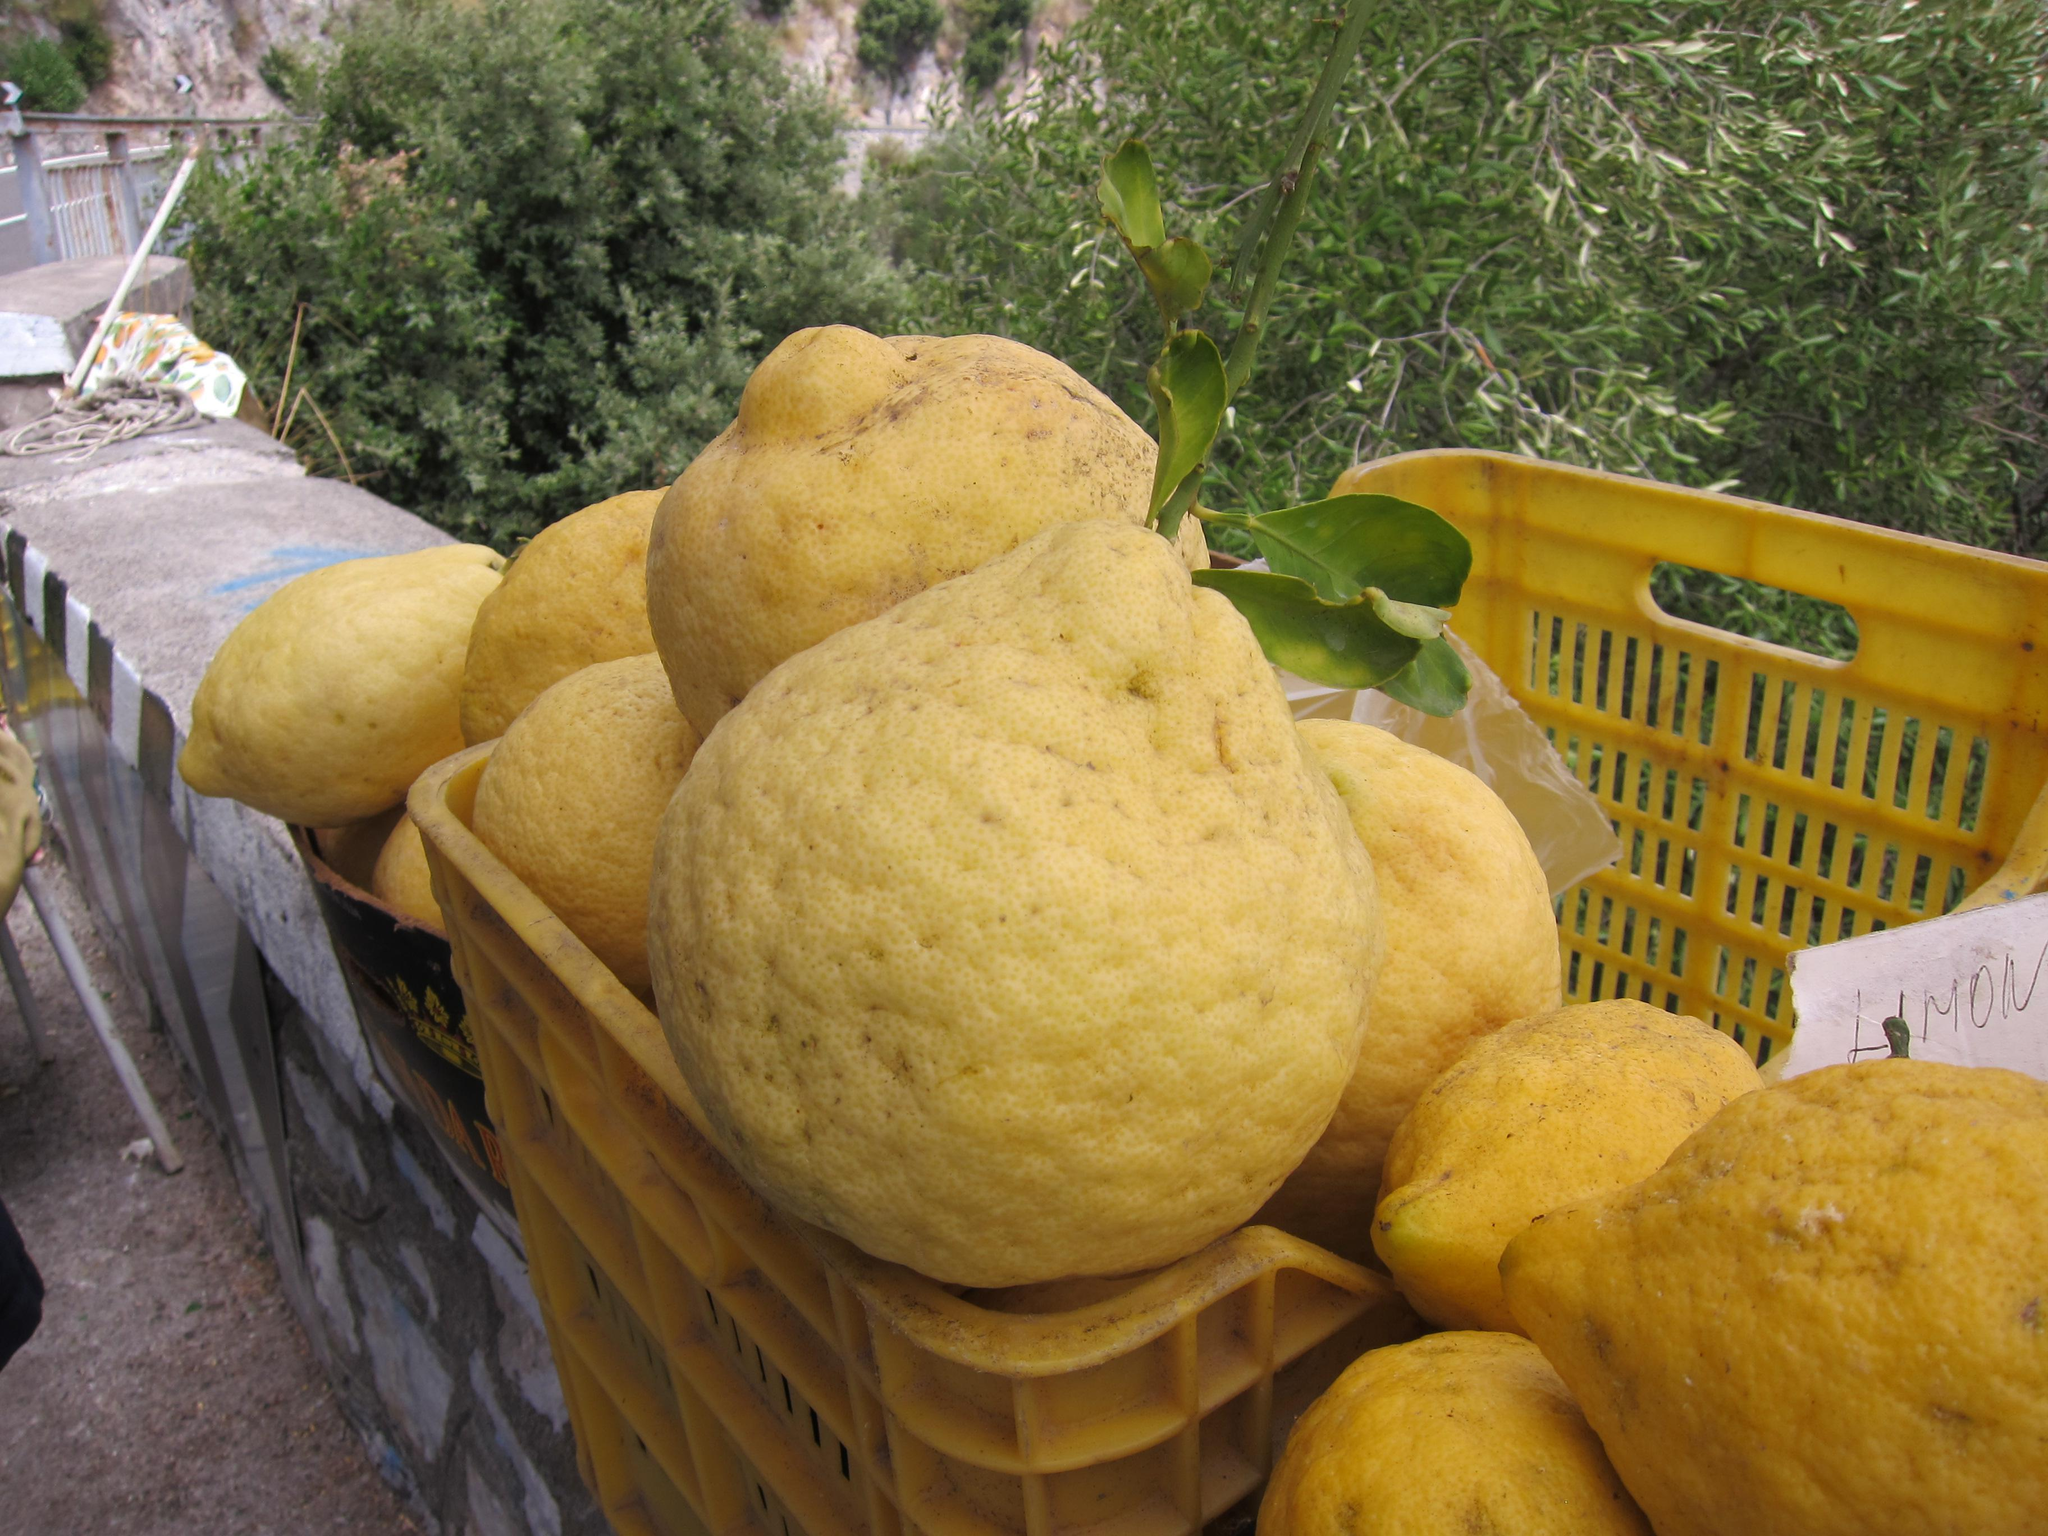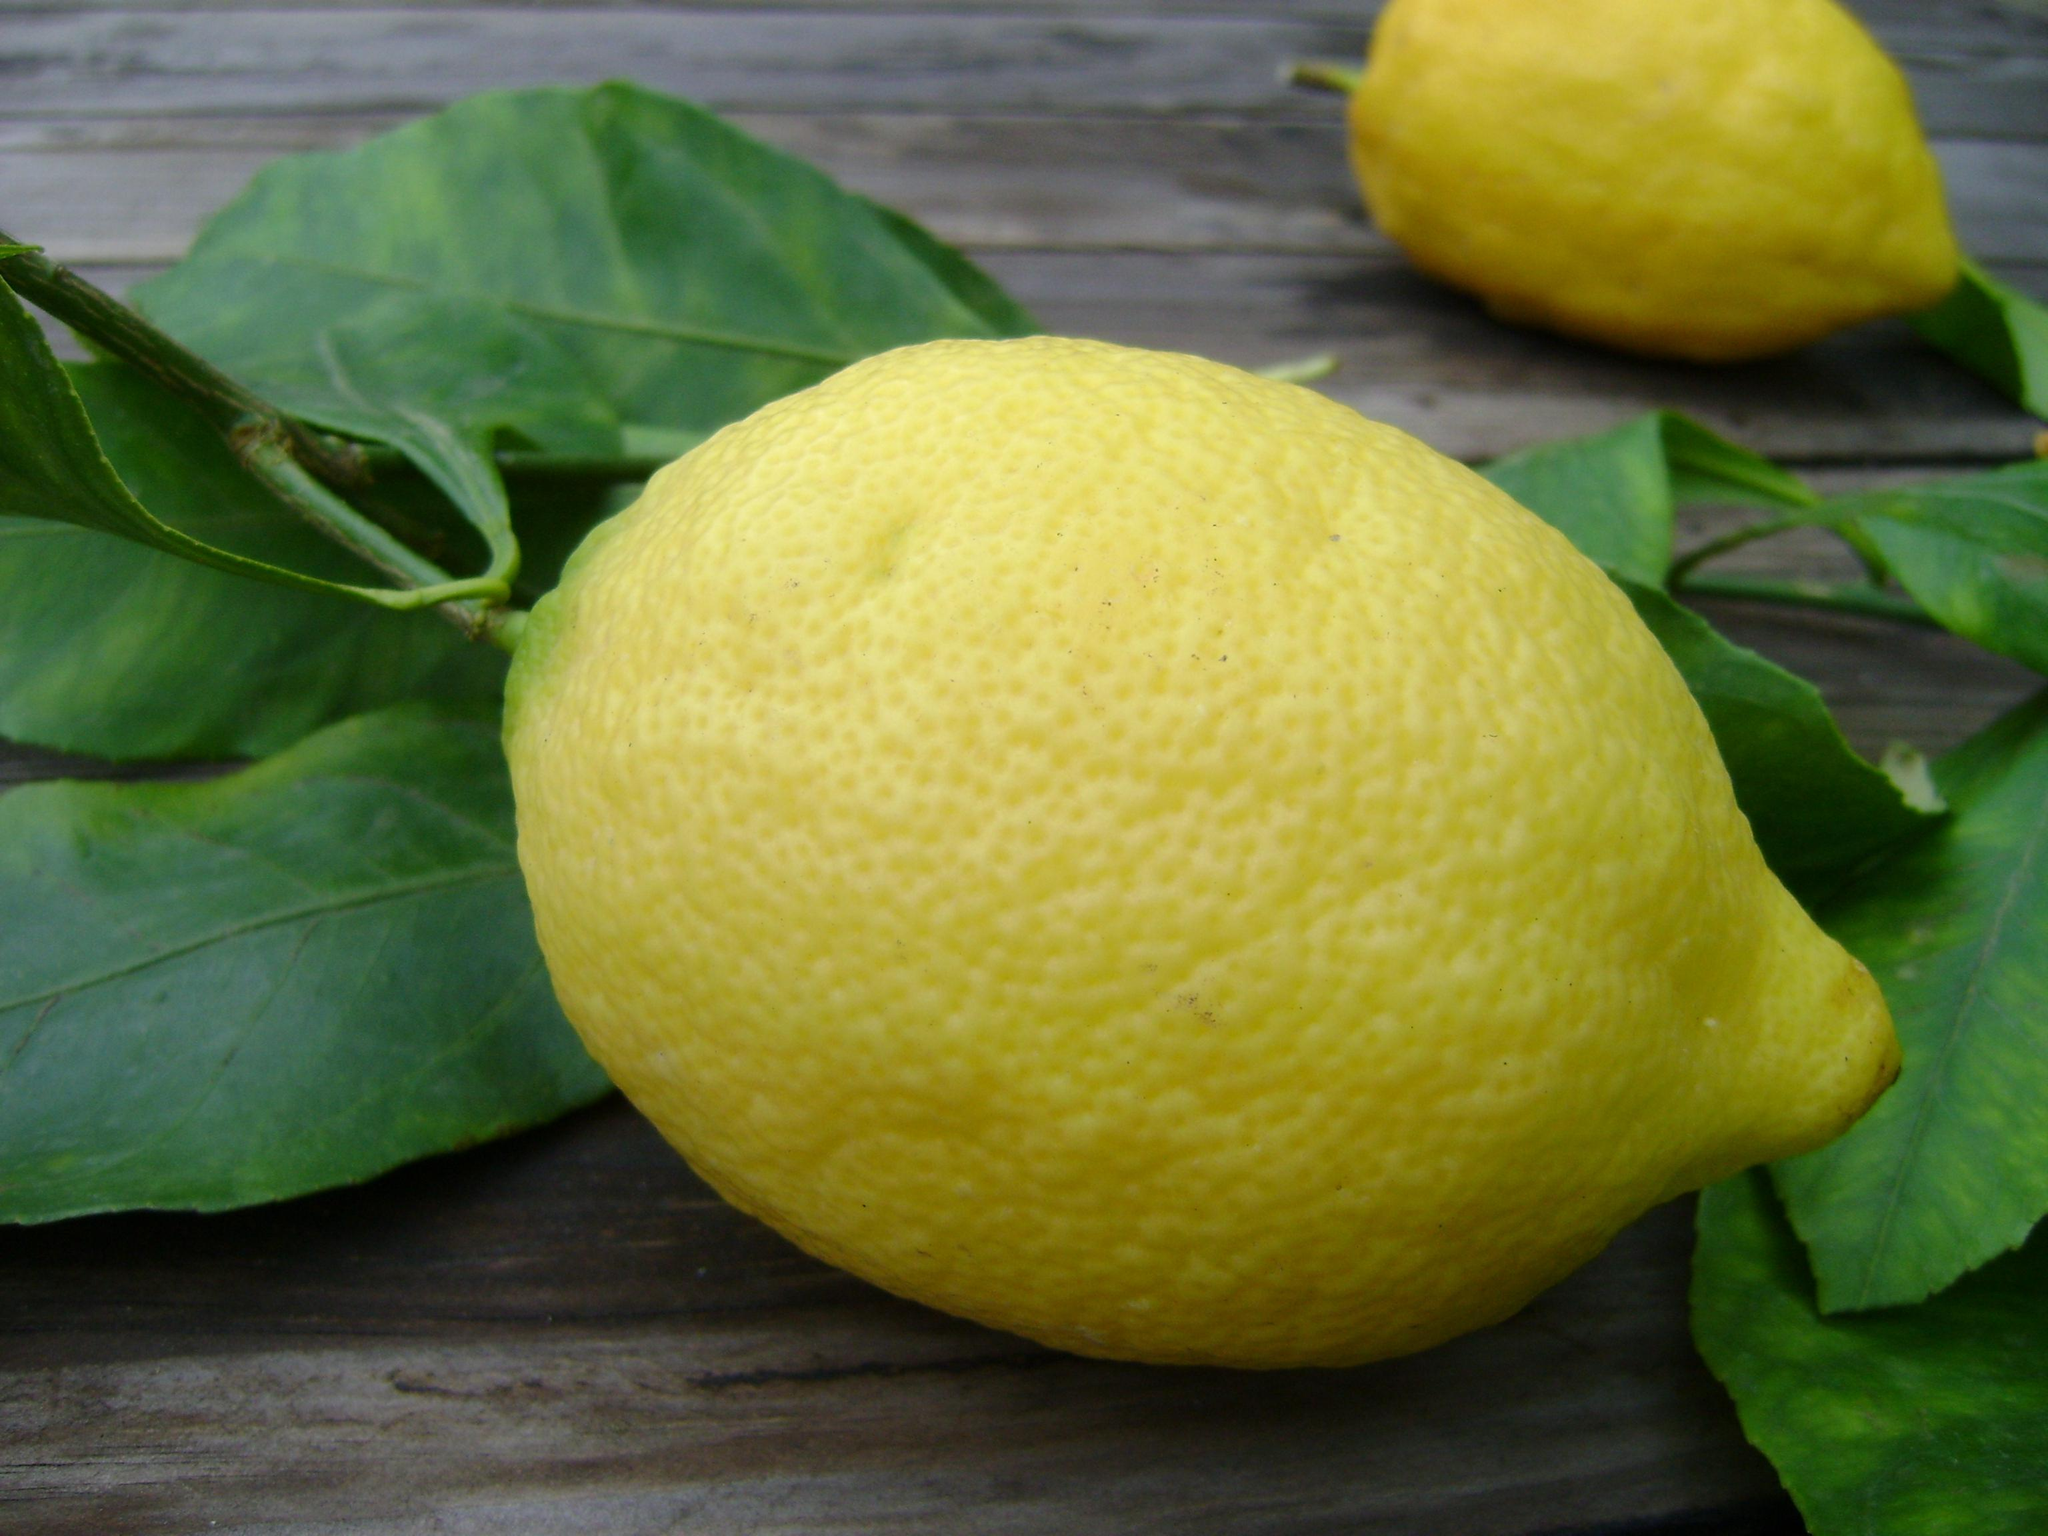The first image is the image on the left, the second image is the image on the right. Evaluate the accuracy of this statement regarding the images: "In at least one image there are no more then four lemons with leaves under them". Is it true? Answer yes or no. Yes. The first image is the image on the left, the second image is the image on the right. Examine the images to the left and right. Is the description "The left image includes a yellow plastic basket containing large yellow dimpled fruits, some with green leaves attached." accurate? Answer yes or no. Yes. 